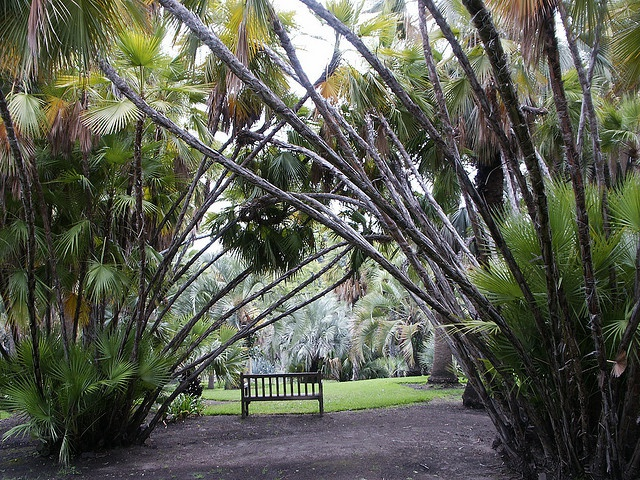Describe the objects in this image and their specific colors. I can see a bench in black, gray, lightgreen, and darkgray tones in this image. 